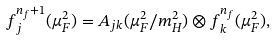<formula> <loc_0><loc_0><loc_500><loc_500>f ^ { n _ { f } + 1 } _ { j } ( \mu _ { F } ^ { 2 } ) = A _ { j k } ( \mu _ { F } ^ { 2 } / m _ { H } ^ { 2 } ) \otimes f ^ { n _ { f } } _ { k } ( \mu _ { F } ^ { 2 } ) ,</formula> 